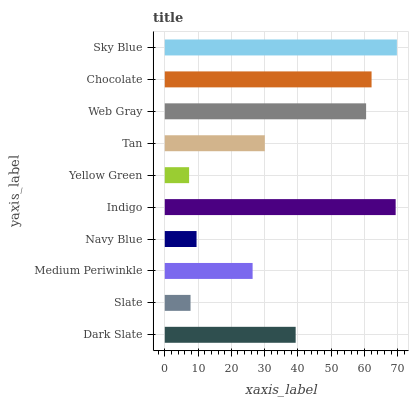Is Yellow Green the minimum?
Answer yes or no. Yes. Is Sky Blue the maximum?
Answer yes or no. Yes. Is Slate the minimum?
Answer yes or no. No. Is Slate the maximum?
Answer yes or no. No. Is Dark Slate greater than Slate?
Answer yes or no. Yes. Is Slate less than Dark Slate?
Answer yes or no. Yes. Is Slate greater than Dark Slate?
Answer yes or no. No. Is Dark Slate less than Slate?
Answer yes or no. No. Is Dark Slate the high median?
Answer yes or no. Yes. Is Tan the low median?
Answer yes or no. Yes. Is Yellow Green the high median?
Answer yes or no. No. Is Medium Periwinkle the low median?
Answer yes or no. No. 